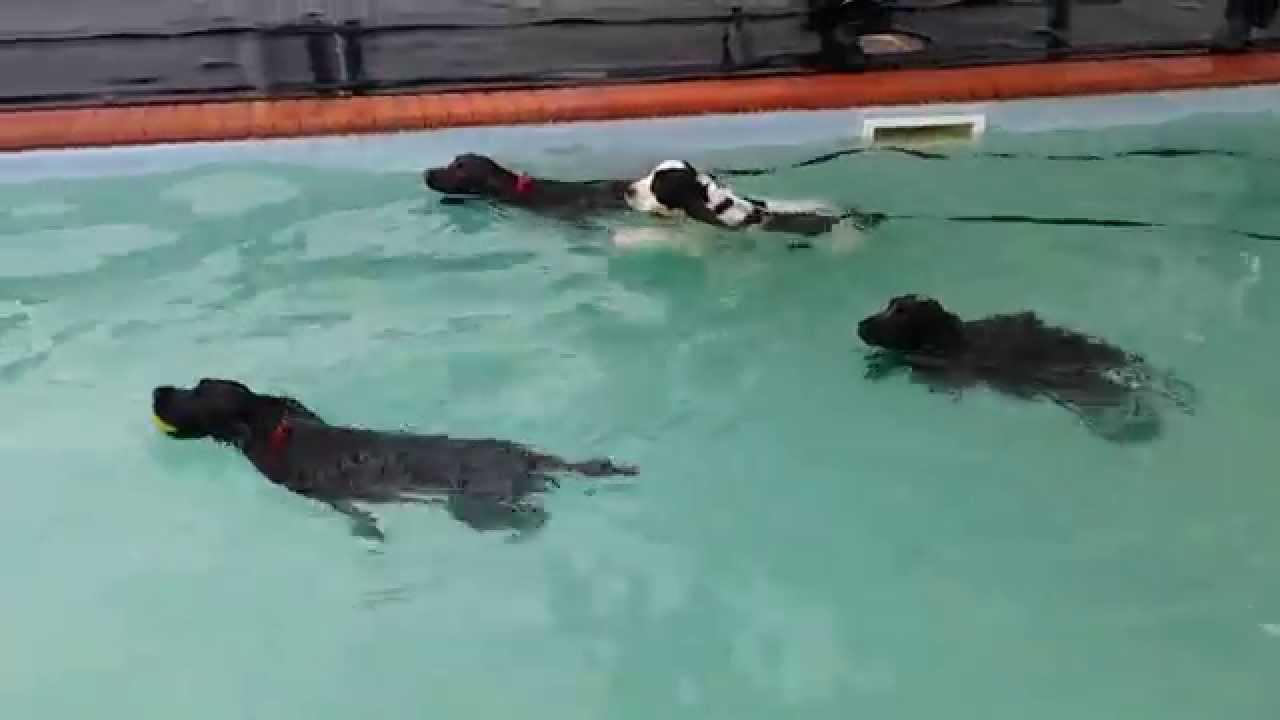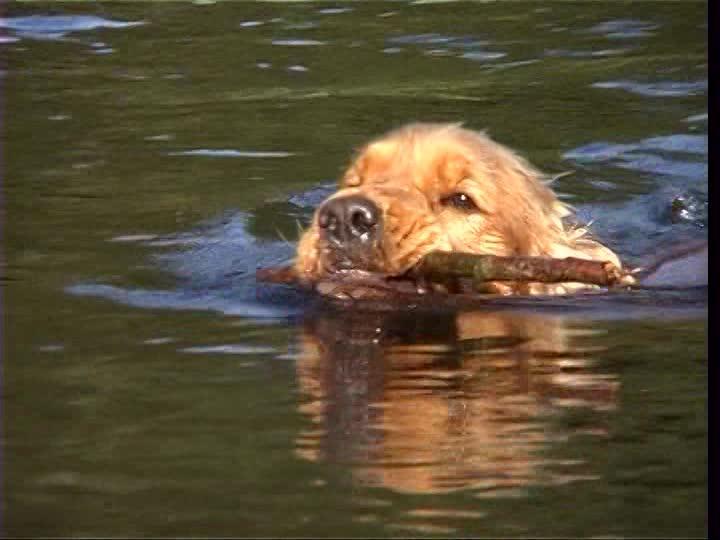The first image is the image on the left, the second image is the image on the right. Examine the images to the left and right. Is the description "One image shows at least three spaniel dogs swimming horizontally in the same direction across a swimming pool." accurate? Answer yes or no. Yes. The first image is the image on the left, the second image is the image on the right. For the images shown, is this caption "In one of the images there are at least three dogs swimming" true? Answer yes or no. Yes. 